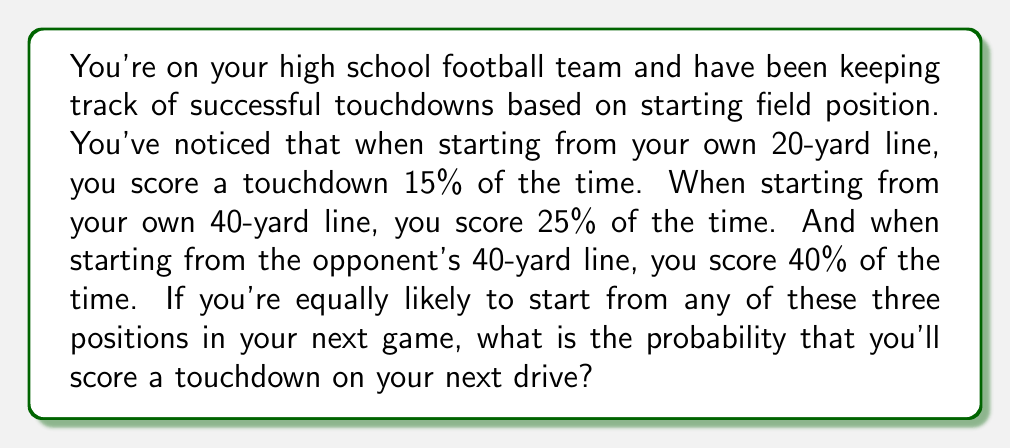Can you answer this question? Let's approach this step-by-step:

1) We have three possible starting positions, each with a different probability of scoring a touchdown:
   - Own 20-yard line: 15% or 0.15
   - Own 40-yard line: 25% or 0.25
   - Opponent's 40-yard line: 40% or 0.40

2) We're told that we're equally likely to start from any of these positions. This means each position has a $\frac{1}{3}$ chance of being our starting point.

3) To find the overall probability, we need to use the law of total probability. We'll multiply the probability of starting at each position by the probability of scoring from that position, then sum these products:

   $$P(\text{touchdown}) = P(\text{own 20}) \cdot P(\text{touchdown|own 20}) + P(\text{own 40}) \cdot P(\text{touchdown|own 40}) + P(\text{opp 40}) \cdot P(\text{touchdown|opp 40})$$

4) Substituting our values:

   $$P(\text{touchdown}) = \frac{1}{3} \cdot 0.15 + \frac{1}{3} \cdot 0.25 + \frac{1}{3} \cdot 0.40$$

5) Simplifying:

   $$P(\text{touchdown}) = \frac{0.15 + 0.25 + 0.40}{3} = \frac{0.80}{3} \approx 0.2667$$

6) Converting to a percentage:

   $$0.2667 \cdot 100\% \approx 26.67\%$$
Answer: 26.67% 